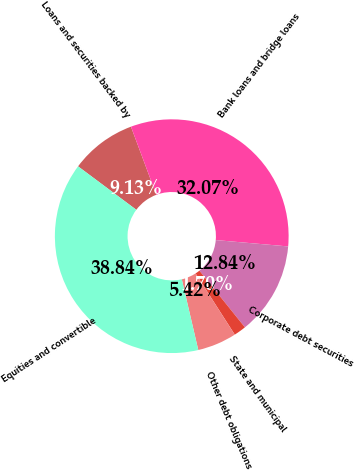Convert chart. <chart><loc_0><loc_0><loc_500><loc_500><pie_chart><fcel>Loans and securities backed by<fcel>Bank loans and bridge loans<fcel>Corporate debt securities<fcel>State and municipal<fcel>Other debt obligations<fcel>Equities and convertible<nl><fcel>9.13%<fcel>32.07%<fcel>12.84%<fcel>1.7%<fcel>5.42%<fcel>38.84%<nl></chart> 